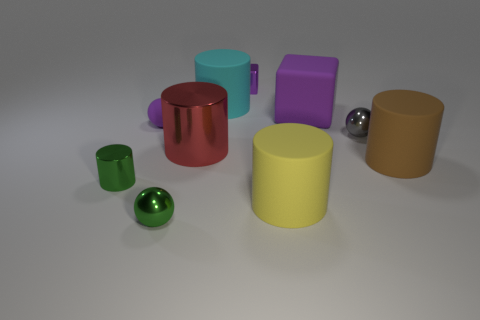Do the big matte thing that is right of the purple rubber cube and the shiny object behind the small gray ball have the same shape?
Give a very brief answer. No. How big is the purple thing that is both in front of the tiny purple metallic object and to the right of the big red metal thing?
Provide a succinct answer. Large. What color is the other large metallic thing that is the same shape as the large cyan object?
Offer a terse response. Red. There is a tiny ball right of the purple block on the left side of the yellow matte cylinder; what is its color?
Ensure brevity in your answer.  Gray. What is the shape of the small matte thing?
Your answer should be compact. Sphere. The big object that is to the left of the metallic cube and behind the red metal cylinder has what shape?
Provide a succinct answer. Cylinder. What color is the tiny cube that is the same material as the small cylinder?
Give a very brief answer. Purple. What shape is the green object behind the tiny thing that is in front of the shiny cylinder that is in front of the brown matte object?
Your answer should be compact. Cylinder. The purple matte cube is what size?
Keep it short and to the point. Large. What is the shape of the tiny gray object that is made of the same material as the red thing?
Your response must be concise. Sphere. 